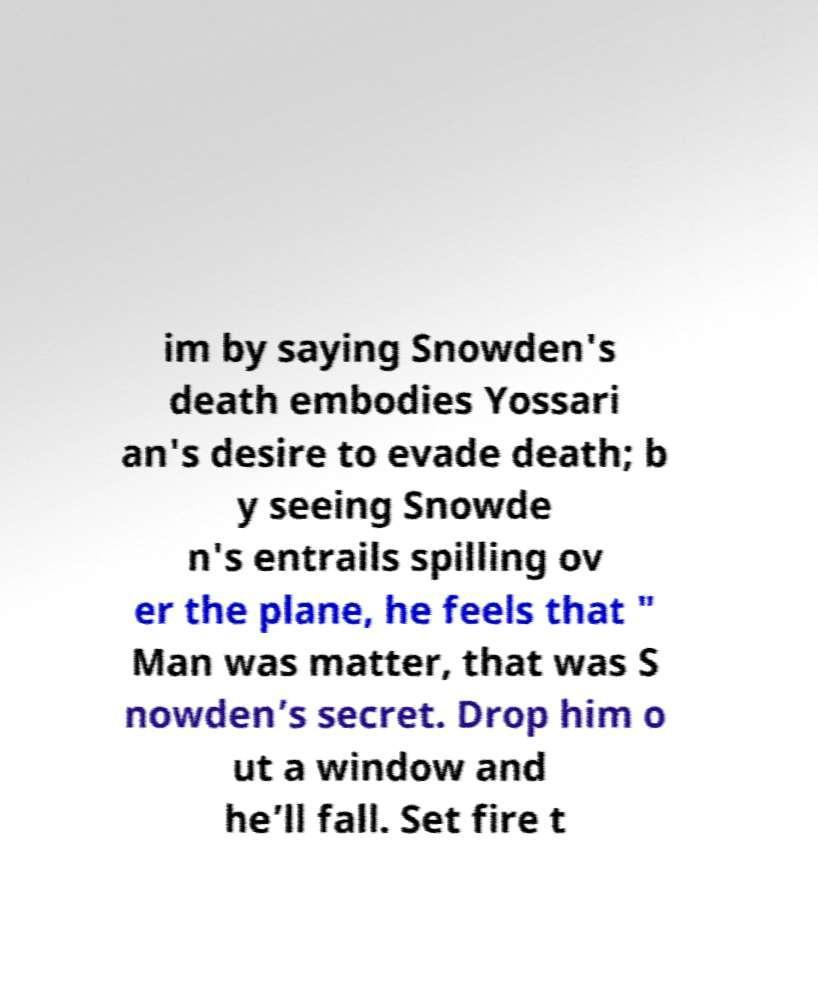For documentation purposes, I need the text within this image transcribed. Could you provide that? im by saying Snowden's death embodies Yossari an's desire to evade death; b y seeing Snowde n's entrails spilling ov er the plane, he feels that " Man was matter, that was S nowden’s secret. Drop him o ut a window and he’ll fall. Set fire t 